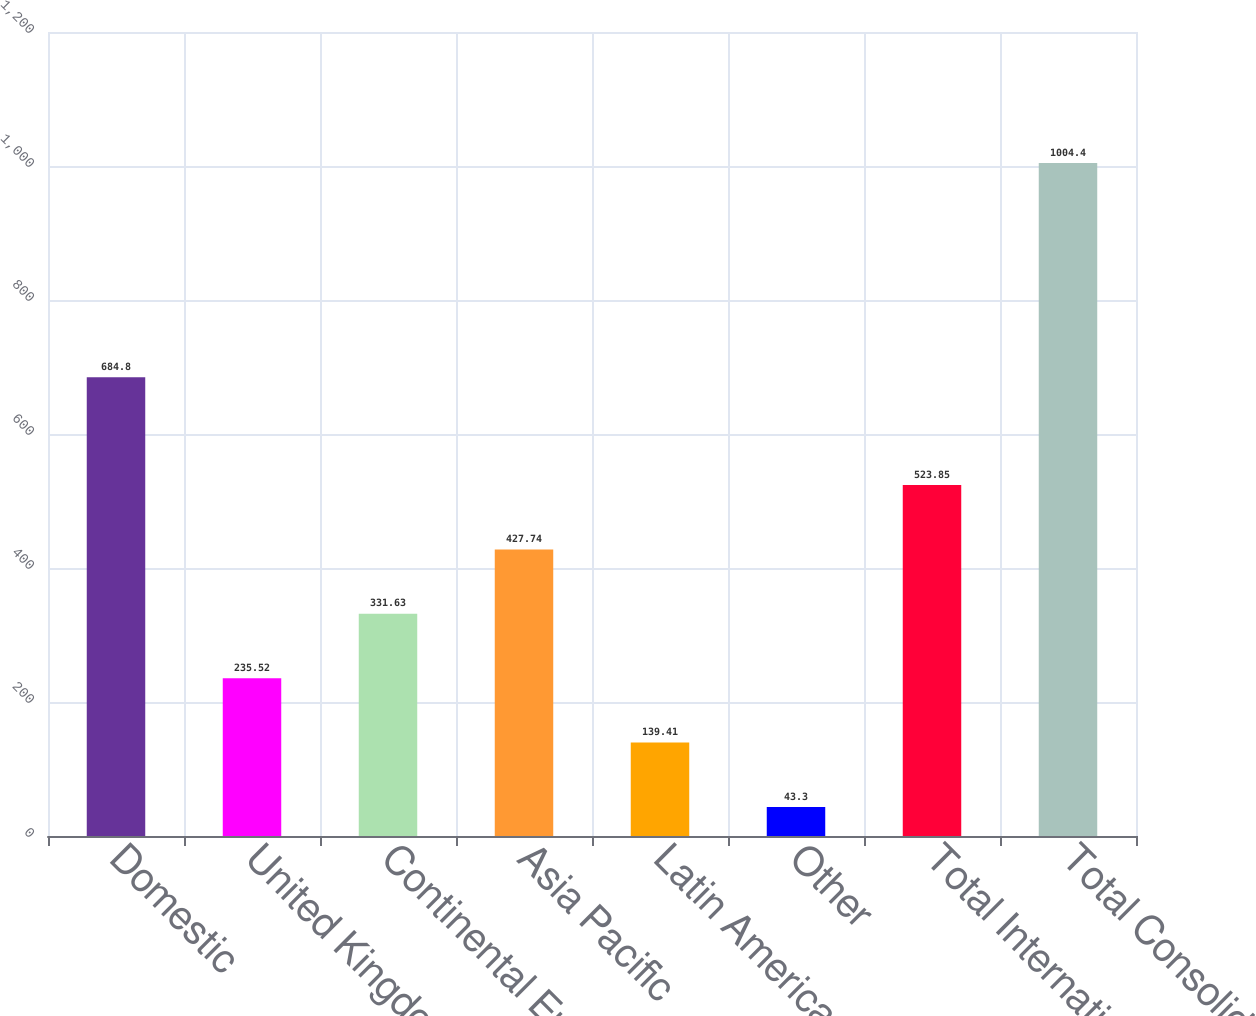Convert chart. <chart><loc_0><loc_0><loc_500><loc_500><bar_chart><fcel>Domestic<fcel>United Kingdom<fcel>Continental Europe<fcel>Asia Pacific<fcel>Latin America<fcel>Other<fcel>Total International<fcel>Total Consolidated<nl><fcel>684.8<fcel>235.52<fcel>331.63<fcel>427.74<fcel>139.41<fcel>43.3<fcel>523.85<fcel>1004.4<nl></chart> 